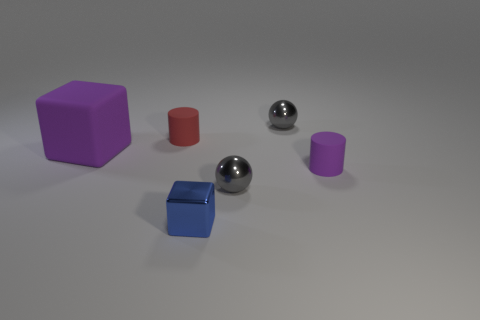Are there any patterns or symmetry in the arrangement of the objects? The objects are spaced out somewhat evenly across the surface, without any distinct pattern or intentional symmetry. The varied positions and orientations of the objects appear random, and there seems to be no obvious order or arrangement that conveys symmetry or a patterned design. 